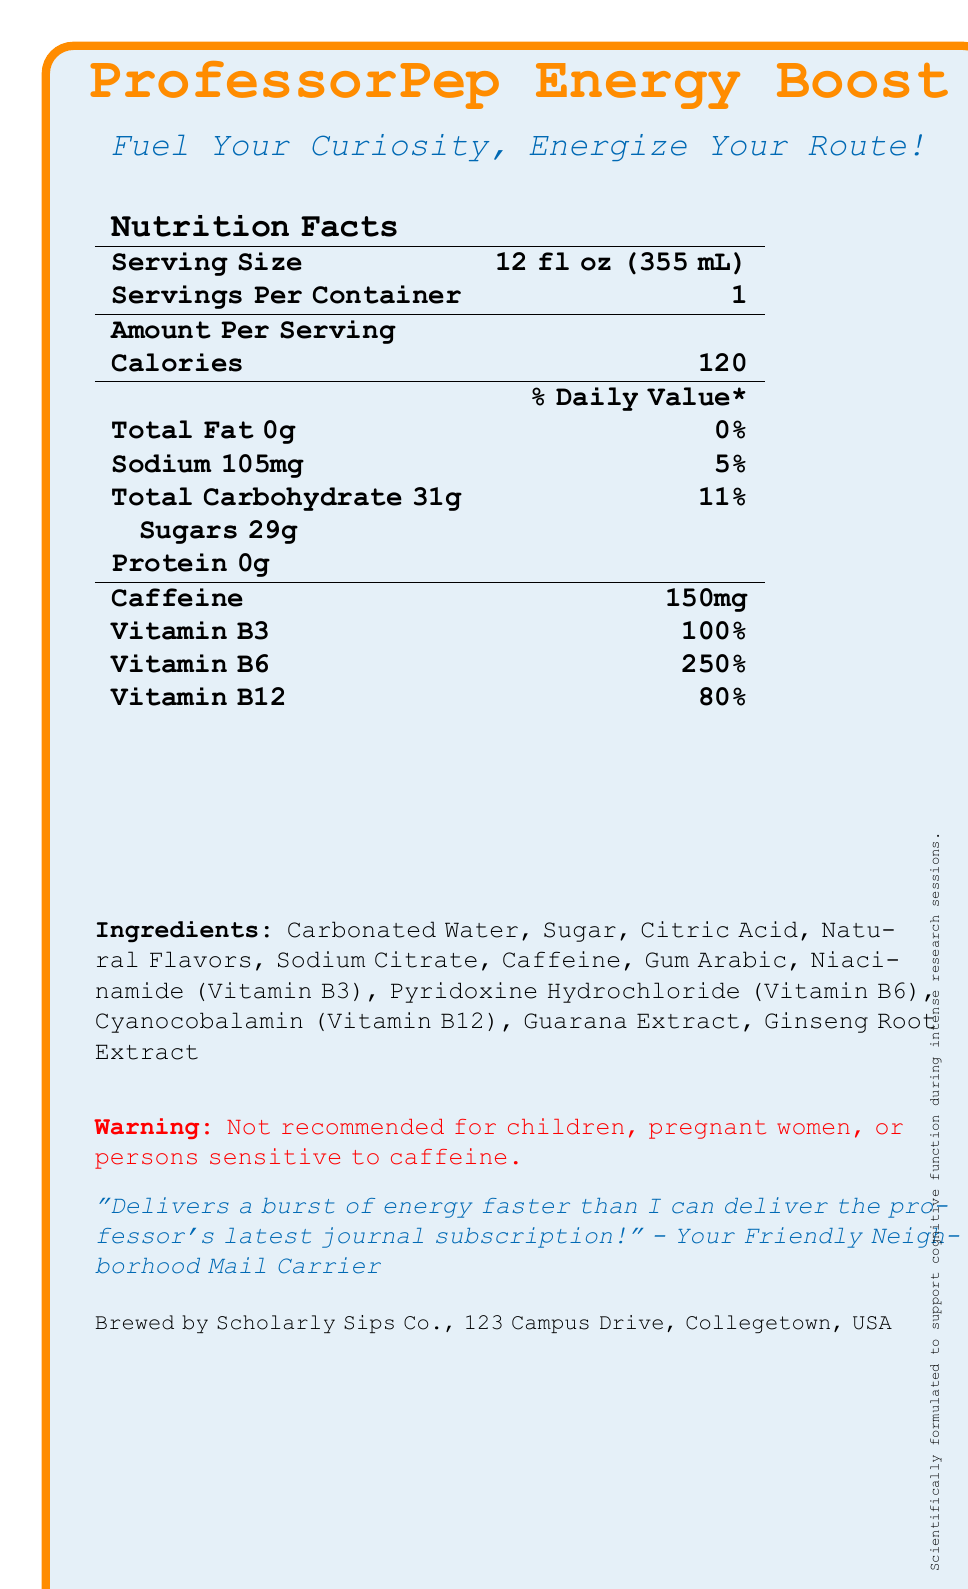What is the serving size of ProfessorPep Energy Boost? The serving size is clearly listed as "12 fl oz (355 mL)" in the nutrition facts section.
Answer: 12 fl oz (355 mL) How many milligrams of sodium are in one serving of this energy drink? The nutrition facts section specifies that there are 105 mg of sodium per serving.
Answer: 105 mg How many grams of sugars does one serving contain? The nutrition facts section states that one serving contains 29 g of sugars.
Answer: 29 g What percentage of the daily value for Vitamin B6 does one serving provide? The nutrition facts indicate that one serving provides 250% of the daily value for Vitamin B6.
Answer: 250% List three ingredients found in ProfessorPep Energy Boost. The ingredients list includes Carbonated Water, Sugar, and Citric Acid among other ingredients.
Answer: Carbonated Water, Sugar, Citric Acid What is the total carbohydrate content per serving? The label shows that the total carbohydrate content per serving is 31 g.
Answer: 31 g Is the energy drink recommended for children? The document has a disclaimer stating that the energy drink is not recommended for children.
Answer: No Which vitamin has the lowest daily value percentage in one serving: Vitamin B3, Vitamin B6, or Vitamin B12? The daily values are 100% for Vitamin B3, 250% for Vitamin B6, and 80% for Vitamin B12. Thus, Vitamin B12 has the lowest percentage.
Answer: Vitamin B12 Where is ProfessorPep Energy Boost manufactured? The manufacturer's information at the bottom of the document indicates that it is brewed by Scholarly Sips Co. at 123 Campus Drive, Collegetown, USA.
Answer: Scholarly Sips Co., 123 Campus Drive, Collegetown, USA What is the flavor profile of the energy drink? The flavor profile is specified as "Zesty Citrus Blast."
Answer: Zesty Citrus Blast How much caffeine does one serving contain? A. 50 mg B. 100 mg C. 150 mg The nutrition facts label indicates that one serving contains 150 mg of caffeine.
Answer: C. 150 mg Which of the following is a special feature of the drink? I. Low in calories II. Formulated to enhance mental alertness III. High protein content The special features section includes "Formulated to enhance mental alertness," but not the other options.
Answer: II. Formulated to enhance mental alertness Does the energy drink boost Vitamin C? The document does not provide any information regarding Vitamin C content.
Answer: Cannot be determined What is the main idea of the document? The document contains nutritional facts, ingredients, special features, a testimonial, and disclaimers related to ProfessorPep Energy Boost, making it clear that the main idea is to inform consumers about the drink’s contents and benefits.
Answer: The document provides detailed nutritional information about ProfessorPep Energy Boost, an energy drink designed to enhance mental alertness with ingredients like caffeine and B-vitamins while cautioning against consumption by children and sensitive individuals. What company endorses the energy drink for cognitive function during research sessions? A small note at the bottom of the document mentions that the drink is scientifically formulated to support cognitive function during intense research sessions, endorsed by Scholarly Sips Co.
Answer: Scholarly Sips Co. How many calories are in one serving of this drink? The nutrition facts section states that there are 120 calories per serving.
Answer: 120 